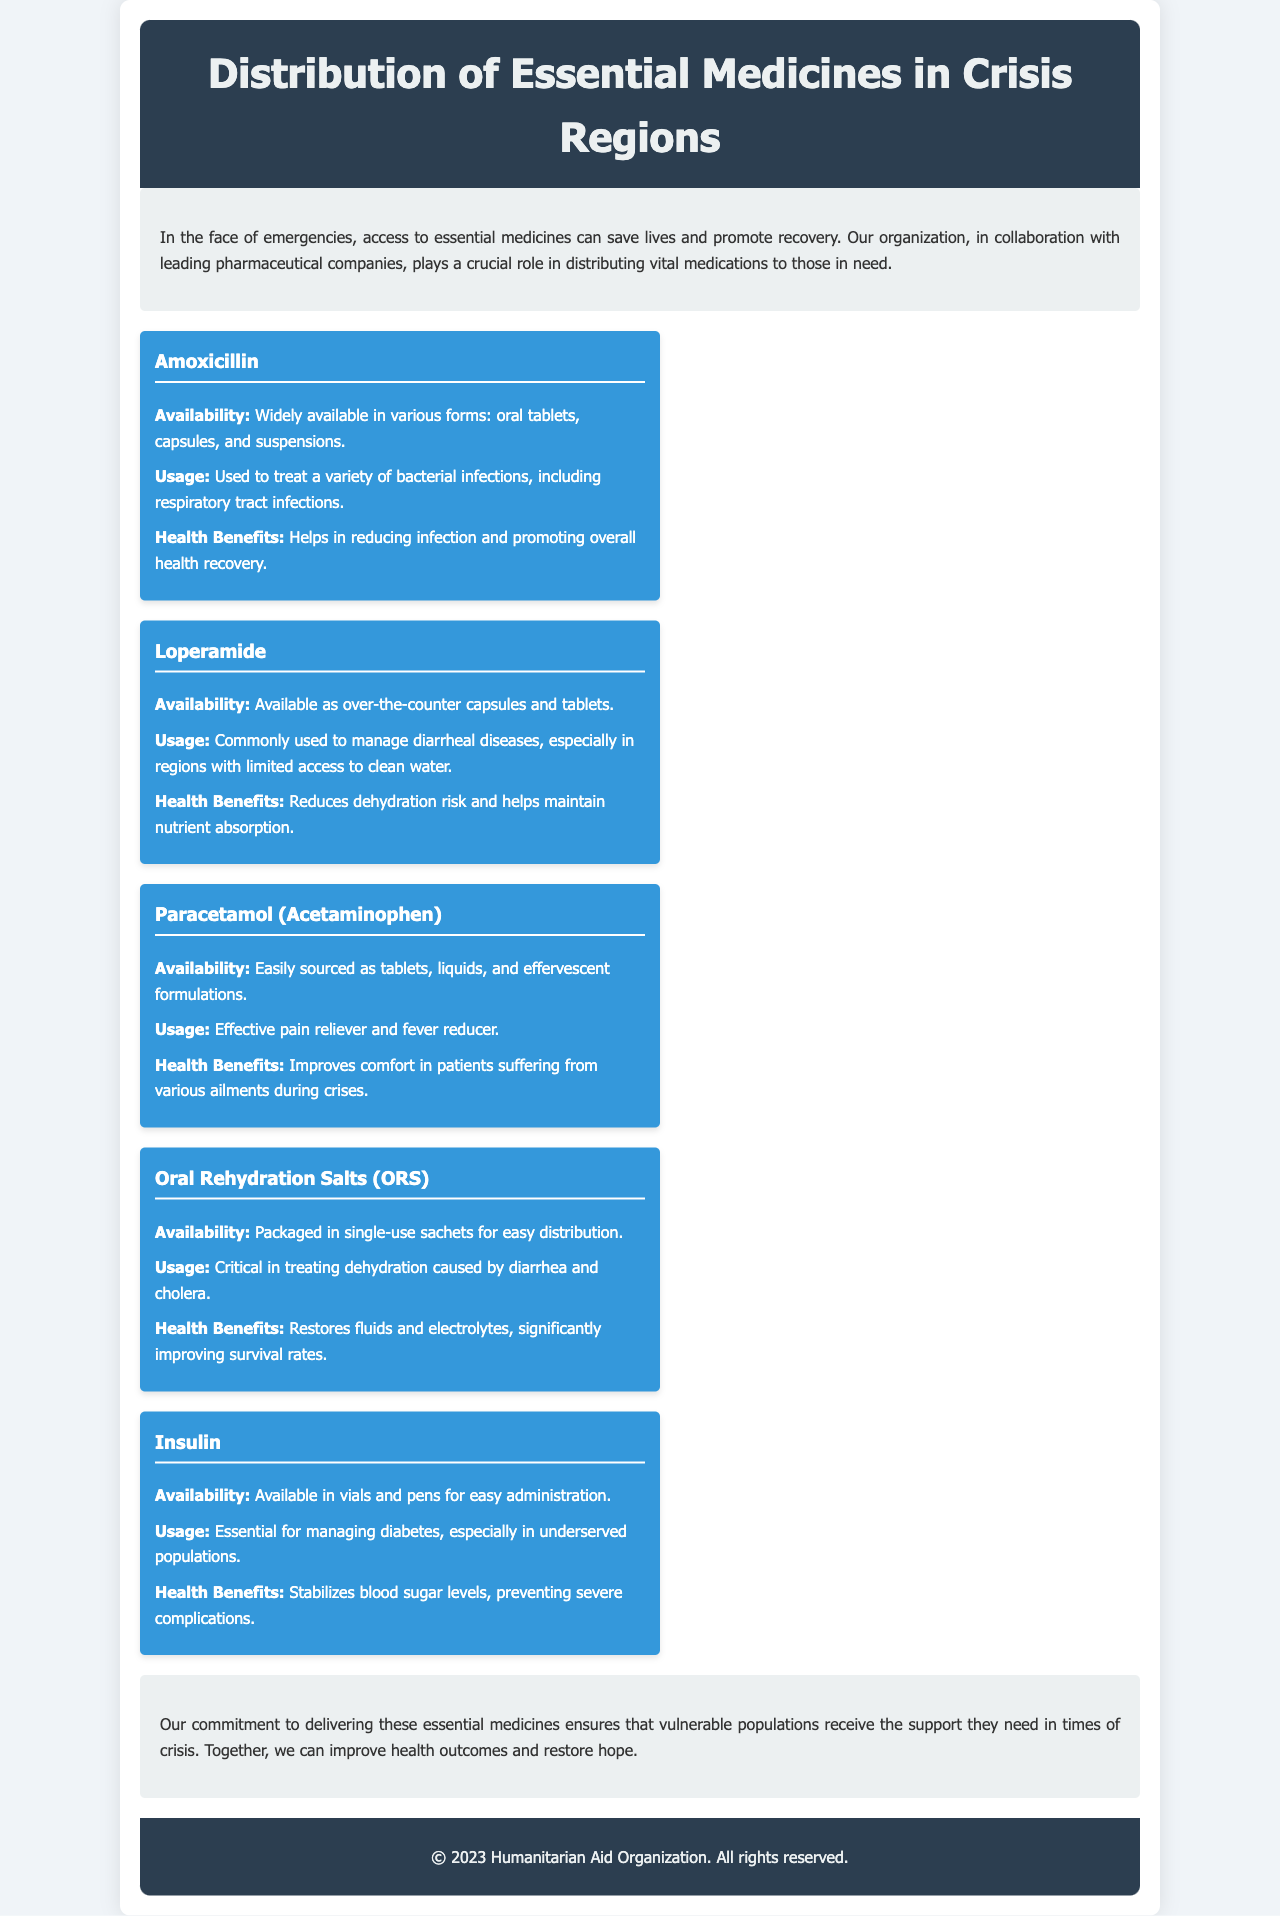what is the title of the brochure? The title of the brochure is prominently displayed at the top, stating the focus on distribution in crisis regions.
Answer: Distribution of Essential Medicines in Crisis Regions which medicine is used to treat dehydration caused by diarrhea? The brochure highlights the specific role of Oral Rehydration Salts in treating dehydration due to diarrhea.
Answer: Oral Rehydration Salts (ORS) what is the main health benefit of Paracetamol? The brochure clearly describes the main health benefit of Paracetamol, emphasizing its role in improving patient comfort.
Answer: Improves comfort in patients how is Insulin made available? The document mentions the forms in which Insulin can be found, as vials and pens for administration.
Answer: Vials and pens what are the two forms available for Loperamide? The brochure outlines the availability of Loperamide specifically as capsules and tablets.
Answer: Capsules and tablets which medicine is noted for treating respiratory tract infections? The document points out that Amoxicillin is specifically used for respiratory tract infections.
Answer: Amoxicillin how many types of oral formulations are mentioned for Paracetamol? The document lists different types of oral formulations available for Paracetamol, requiring a count of the listed forms.
Answer: Three types what is emphasized as critical in managing diabetes in crisis regions? The text focuses on the importance of Insulin for managing diabetes among underserved populations.
Answer: Insulin what partnership is highlighted in the brochure? The brochure mentions collaboration with pharmaceutical companies for medicine distribution.
Answer: Leading pharmaceutical companies 